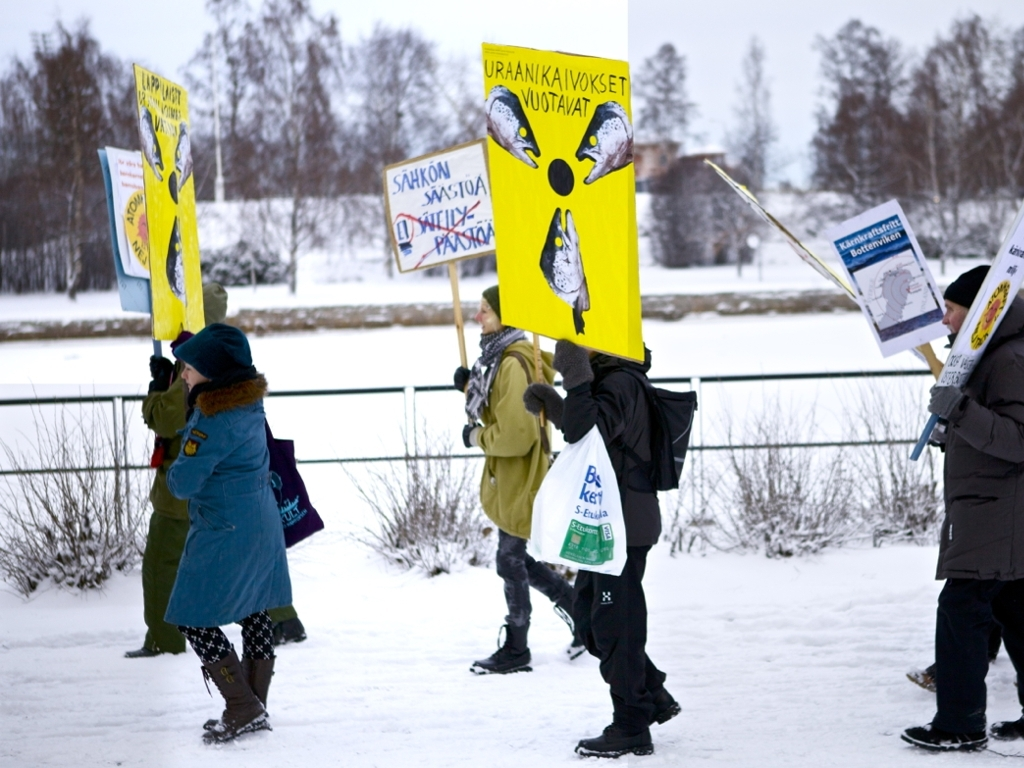How visible are the text and details on the promotional sign?
A. Partially visible
B. Completely invisible
C. Clearly visible The text and details on the promotional signs are clearly visible, despite the overcast weather conditions. The signs feature contrasting colors, bold lettering, and large illustrations that stand out against the snowy background. This makes the information on the signs accessible to onlookers, effectively conveying the message of the demonstrators. 